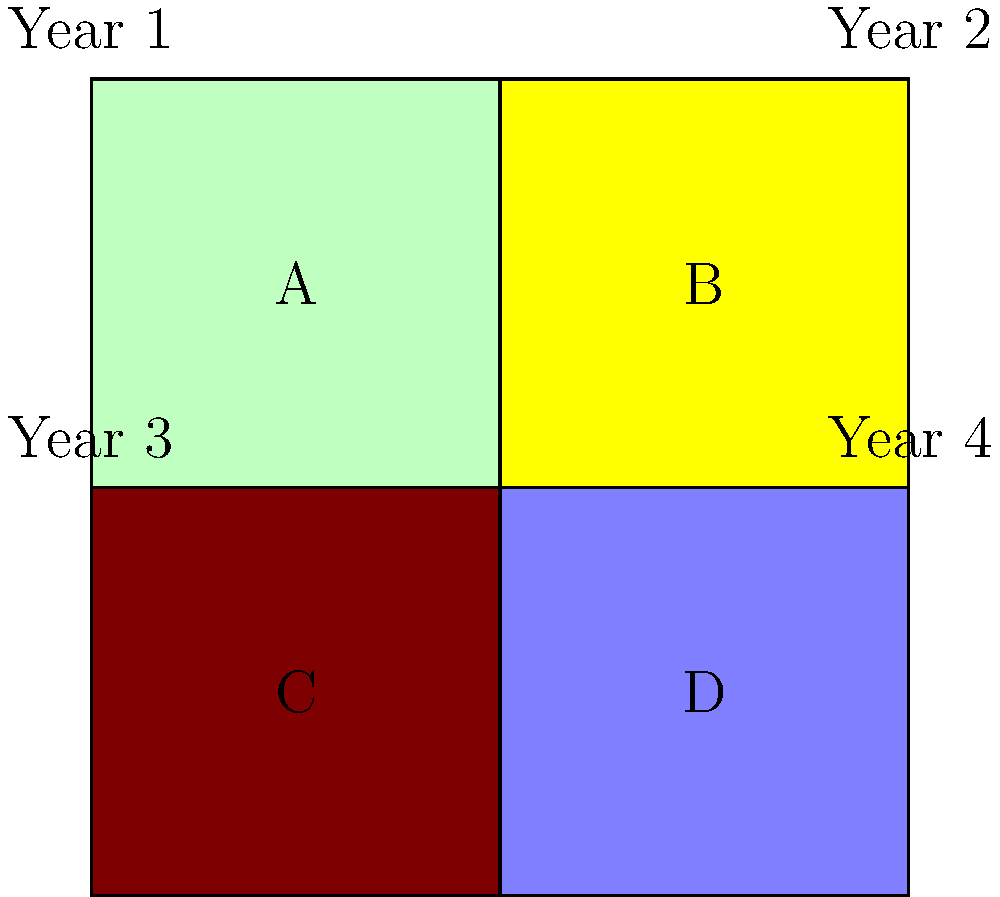Based on the field layout diagram showing a four-year crop rotation plan, which field should be planted with nitrogen-fixing legumes in Year 3 to best maintain soil fertility and crop yield? To determine the optimal field for planting nitrogen-fixing legumes in Year 3, we need to consider the principles of crop rotation and soil management:

1. Crop rotation typically follows a pattern to maximize soil fertility and minimize pest and disease issues.

2. Legumes are usually planted after crops that deplete soil nitrogen, as they can replenish it.

3. Looking at the diagram:
   - Year 1: Field A (green) likely represents a nitrogen-demanding crop like corn or wheat.
   - Year 2: Field B (yellow) might be a root crop or another heavy feeder.
   - Year 3: We need to choose between fields C and D.
   - Year 4: The remaining field will be used.

4. Field C (brown) in Year 3 is the logical choice for legumes because:
   - It follows two years of potentially heavy nitrogen-depleting crops.
   - Planting legumes here will replenish nitrogen for the crop in Field D in Year 4.
   - This maintains a balanced nutrient cycle across all four fields over the rotation period.

5. Field D (light blue) in Year 4 can then be used for a crop that benefits from the nitrogen fixed by the legumes in the previous year.

Therefore, to best maintain soil fertility and crop yield, Field C should be planted with nitrogen-fixing legumes in Year 3.
Answer: Field C 